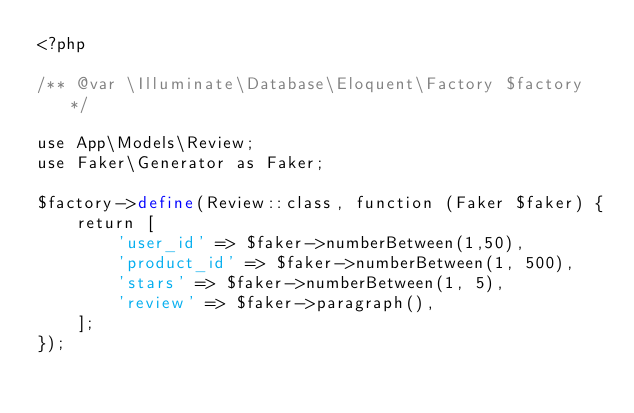Convert code to text. <code><loc_0><loc_0><loc_500><loc_500><_PHP_><?php

/** @var \Illuminate\Database\Eloquent\Factory $factory */

use App\Models\Review;
use Faker\Generator as Faker;

$factory->define(Review::class, function (Faker $faker) {
    return [
        'user_id' => $faker->numberBetween(1,50),
        'product_id' => $faker->numberBetween(1, 500),
        'stars' => $faker->numberBetween(1, 5),
        'review' => $faker->paragraph(),
    ];
});
</code> 